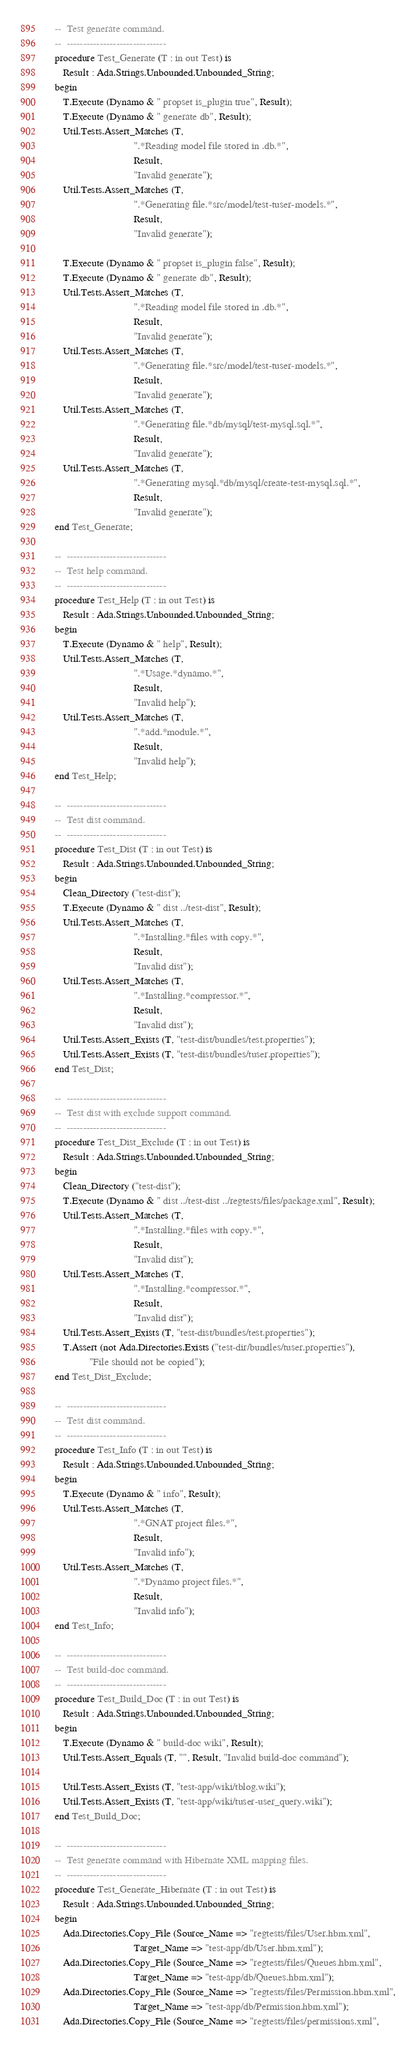<code> <loc_0><loc_0><loc_500><loc_500><_Ada_>   --  Test generate command.
   --  ------------------------------
   procedure Test_Generate (T : in out Test) is
      Result : Ada.Strings.Unbounded.Unbounded_String;
   begin
      T.Execute (Dynamo & " propset is_plugin true", Result);
      T.Execute (Dynamo & " generate db", Result);
      Util.Tests.Assert_Matches (T,
                                 ".*Reading model file stored in .db.*",
                                 Result,
                                 "Invalid generate");
      Util.Tests.Assert_Matches (T,
                                 ".*Generating file.*src/model/test-tuser-models.*",
                                 Result,
                                 "Invalid generate");

      T.Execute (Dynamo & " propset is_plugin false", Result);
      T.Execute (Dynamo & " generate db", Result);
      Util.Tests.Assert_Matches (T,
                                 ".*Reading model file stored in .db.*",
                                 Result,
                                 "Invalid generate");
      Util.Tests.Assert_Matches (T,
                                 ".*Generating file.*src/model/test-tuser-models.*",
                                 Result,
                                 "Invalid generate");
      Util.Tests.Assert_Matches (T,
                                 ".*Generating file.*db/mysql/test-mysql.sql.*",
                                 Result,
                                 "Invalid generate");
      Util.Tests.Assert_Matches (T,
                                 ".*Generating mysql.*db/mysql/create-test-mysql.sql.*",
                                 Result,
                                 "Invalid generate");
   end Test_Generate;

   --  ------------------------------
   --  Test help command.
   --  ------------------------------
   procedure Test_Help (T : in out Test) is
      Result : Ada.Strings.Unbounded.Unbounded_String;
   begin
      T.Execute (Dynamo & " help", Result);
      Util.Tests.Assert_Matches (T,
                                 ".*Usage.*dynamo.*",
                                 Result,
                                 "Invalid help");
      Util.Tests.Assert_Matches (T,
                                 ".*add.*module.*",
                                 Result,
                                 "Invalid help");
   end Test_Help;

   --  ------------------------------
   --  Test dist command.
   --  ------------------------------
   procedure Test_Dist (T : in out Test) is
      Result : Ada.Strings.Unbounded.Unbounded_String;
   begin
      Clean_Directory ("test-dist");
      T.Execute (Dynamo & " dist ../test-dist", Result);
      Util.Tests.Assert_Matches (T,
                                 ".*Installing.*files with copy.*",
                                 Result,
                                 "Invalid dist");
      Util.Tests.Assert_Matches (T,
                                 ".*Installing.*compressor.*",
                                 Result,
                                 "Invalid dist");
      Util.Tests.Assert_Exists (T, "test-dist/bundles/test.properties");
      Util.Tests.Assert_Exists (T, "test-dist/bundles/tuser.properties");
   end Test_Dist;

   --  ------------------------------
   --  Test dist with exclude support command.
   --  ------------------------------
   procedure Test_Dist_Exclude (T : in out Test) is
      Result : Ada.Strings.Unbounded.Unbounded_String;
   begin
      Clean_Directory ("test-dist");
      T.Execute (Dynamo & " dist ../test-dist ../regtests/files/package.xml", Result);
      Util.Tests.Assert_Matches (T,
                                 ".*Installing.*files with copy.*",
                                 Result,
                                 "Invalid dist");
      Util.Tests.Assert_Matches (T,
                                 ".*Installing.*compressor.*",
                                 Result,
                                 "Invalid dist");
      Util.Tests.Assert_Exists (T, "test-dist/bundles/test.properties");
      T.Assert (not Ada.Directories.Exists ("test-dir/bundles/tuser.properties"),
                "File should not be copied");
   end Test_Dist_Exclude;

   --  ------------------------------
   --  Test dist command.
   --  ------------------------------
   procedure Test_Info (T : in out Test) is
      Result : Ada.Strings.Unbounded.Unbounded_String;
   begin
      T.Execute (Dynamo & " info", Result);
      Util.Tests.Assert_Matches (T,
                                 ".*GNAT project files.*",
                                 Result,
                                 "Invalid info");
      Util.Tests.Assert_Matches (T,
                                 ".*Dynamo project files.*",
                                 Result,
                                 "Invalid info");
   end Test_Info;

   --  ------------------------------
   --  Test build-doc command.
   --  ------------------------------
   procedure Test_Build_Doc (T : in out Test) is
      Result : Ada.Strings.Unbounded.Unbounded_String;
   begin
      T.Execute (Dynamo & " build-doc wiki", Result);
      Util.Tests.Assert_Equals (T, "", Result, "Invalid build-doc command");

      Util.Tests.Assert_Exists (T, "test-app/wiki/tblog.wiki");
      Util.Tests.Assert_Exists (T, "test-app/wiki/tuser-user_query.wiki");
   end Test_Build_Doc;

   --  ------------------------------
   --  Test generate command with Hibernate XML mapping files.
   --  ------------------------------
   procedure Test_Generate_Hibernate (T : in out Test) is
      Result : Ada.Strings.Unbounded.Unbounded_String;
   begin
      Ada.Directories.Copy_File (Source_Name => "regtests/files/User.hbm.xml",
                                 Target_Name => "test-app/db/User.hbm.xml");
      Ada.Directories.Copy_File (Source_Name => "regtests/files/Queues.hbm.xml",
                                 Target_Name => "test-app/db/Queues.hbm.xml");
      Ada.Directories.Copy_File (Source_Name => "regtests/files/Permission.hbm.xml",
                                 Target_Name => "test-app/db/Permission.hbm.xml");
      Ada.Directories.Copy_File (Source_Name => "regtests/files/permissions.xml",</code> 